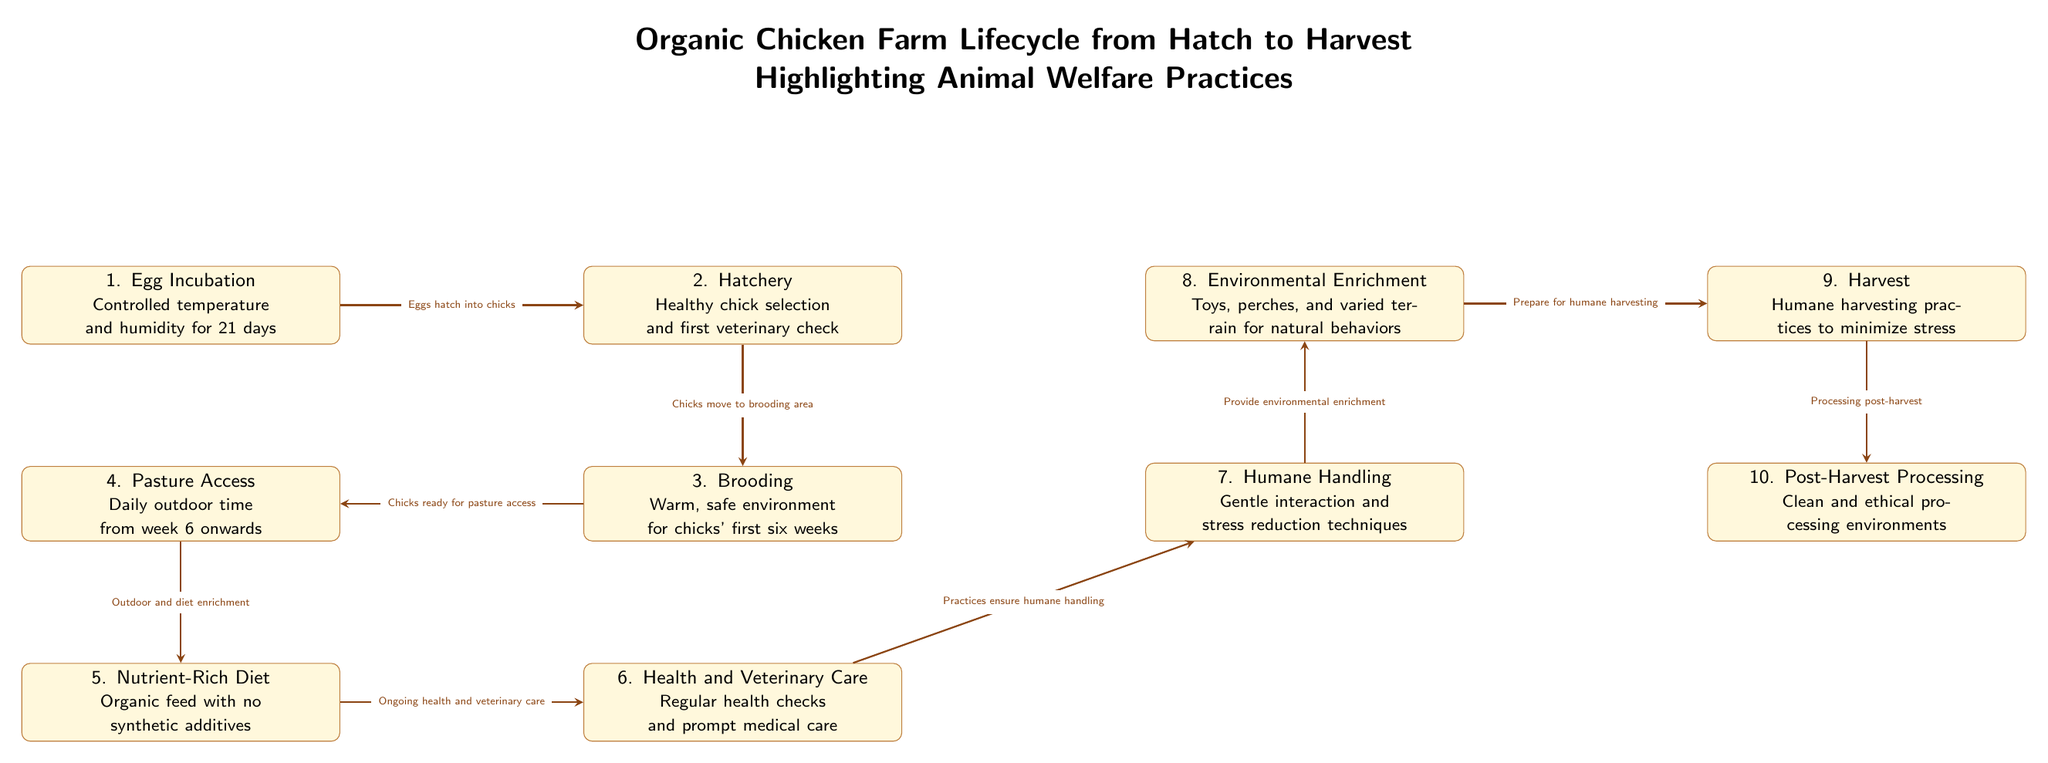What is the first step in the lifecycle? The first step in the lifecycle is identified in the diagram as "Egg Incubation", where eggs are kept in controlled temperature and humidity for 21 days.
Answer: Egg Incubation How many nodes are there in the diagram? By counting each distinct rectangular component (representing steps in the lifecycle), we see there are a total of ten nodes represented in the diagram.
Answer: 10 What practice is highlighted during Harvest? The diagram indicates that "Humane harvesting practices to minimize stress" is the key practice highlighted during the Harvest stage, focusing on animal welfare.
Answer: Humane harvesting practices What connects Brooding and Pasture Access? The connection from "Brooding" to "Pasture Access" indicates that "Chicks ready for pasture access," which is a direct transition as chicks progress into outdoor environments.
Answer: Chicks ready for pasture access Which two nodes emphasize animal welfare through veterinary care? The nodes "Health and Veterinary Care" and "Humane Handling" both emphasize animal welfare practices by describing the ongoing health checks and humane treatment of the chickens.
Answer: Health and Veterinary Care, Humane Handling How many edges exist in the diagram? By tracing the arrows that connect the nodes, we find there are a total of nine edges that illustrate the flow from one step to the next in the lifecycle.
Answer: 9 What type of diet is provided in the Nutrient-Rich Diet stage? The Nutrient-Rich Diet node specifies that "Organic feed with no synthetic additives" is provided to ensure the health and welfare of the chickens.
Answer: Organic feed with no synthetic additives What is the final step after Harvest? The diagram clearly indicates that the final step is "Post-Harvest Processing", occurring directly after the harvesting practices are completed.
Answer: Post-Harvest Processing 